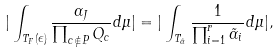<formula> <loc_0><loc_0><loc_500><loc_500>| \int _ { T _ { F } ( \epsilon ) } \frac { \alpha _ { J } } { \prod _ { c \not \in P } Q _ { c } } d \mu | = | \int _ { T _ { \tilde { \alpha } } } \frac { 1 } { \prod _ { i = 1 } ^ { r } \tilde { \alpha } _ { i } } d \mu | ,</formula> 